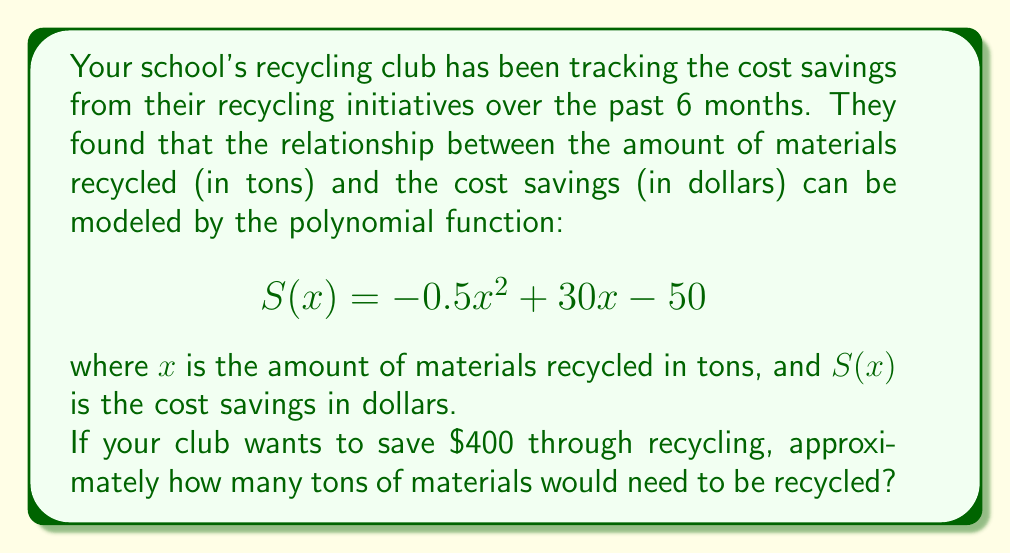Show me your answer to this math problem. To solve this problem, we need to find the value of $x$ when $S(x) = 400$. This involves solving a quadratic equation:

1) Set up the equation:
   $$400 = -0.5x^2 + 30x - 50$$

2) Rearrange the equation to standard form $(ax^2 + bx + c = 0)$:
   $$0.5x^2 - 30x + 450 = 0$$

3) Use the quadratic formula: $x = \frac{-b \pm \sqrt{b^2 - 4ac}}{2a}$
   Where $a = 0.5$, $b = -30$, and $c = 450$

4) Substitute these values into the quadratic formula:
   $$x = \frac{30 \pm \sqrt{(-30)^2 - 4(0.5)(450)}}{2(0.5)}$$

5) Simplify:
   $$x = \frac{30 \pm \sqrt{900 - 900}}{1} = \frac{30 \pm 0}{1} = 30$$

Therefore, the club would need to recycle approximately 30 tons of materials to save $400.

To verify:
$$S(30) = -0.5(30)^2 + 30(30) - 50 = -450 + 900 - 50 = 400$$
Answer: Approximately 30 tons of materials need to be recycled to save $400. 